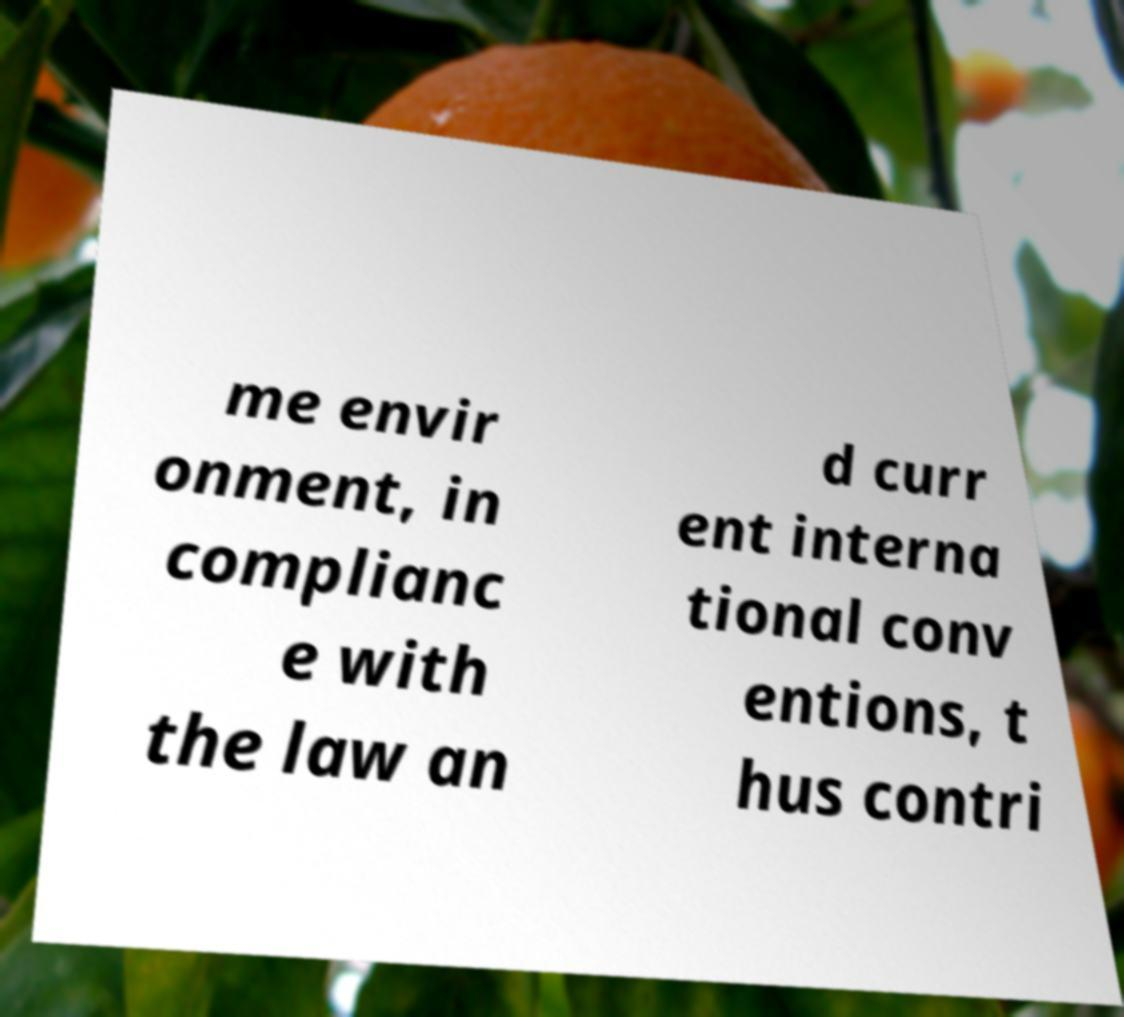Could you assist in decoding the text presented in this image and type it out clearly? me envir onment, in complianc e with the law an d curr ent interna tional conv entions, t hus contri 